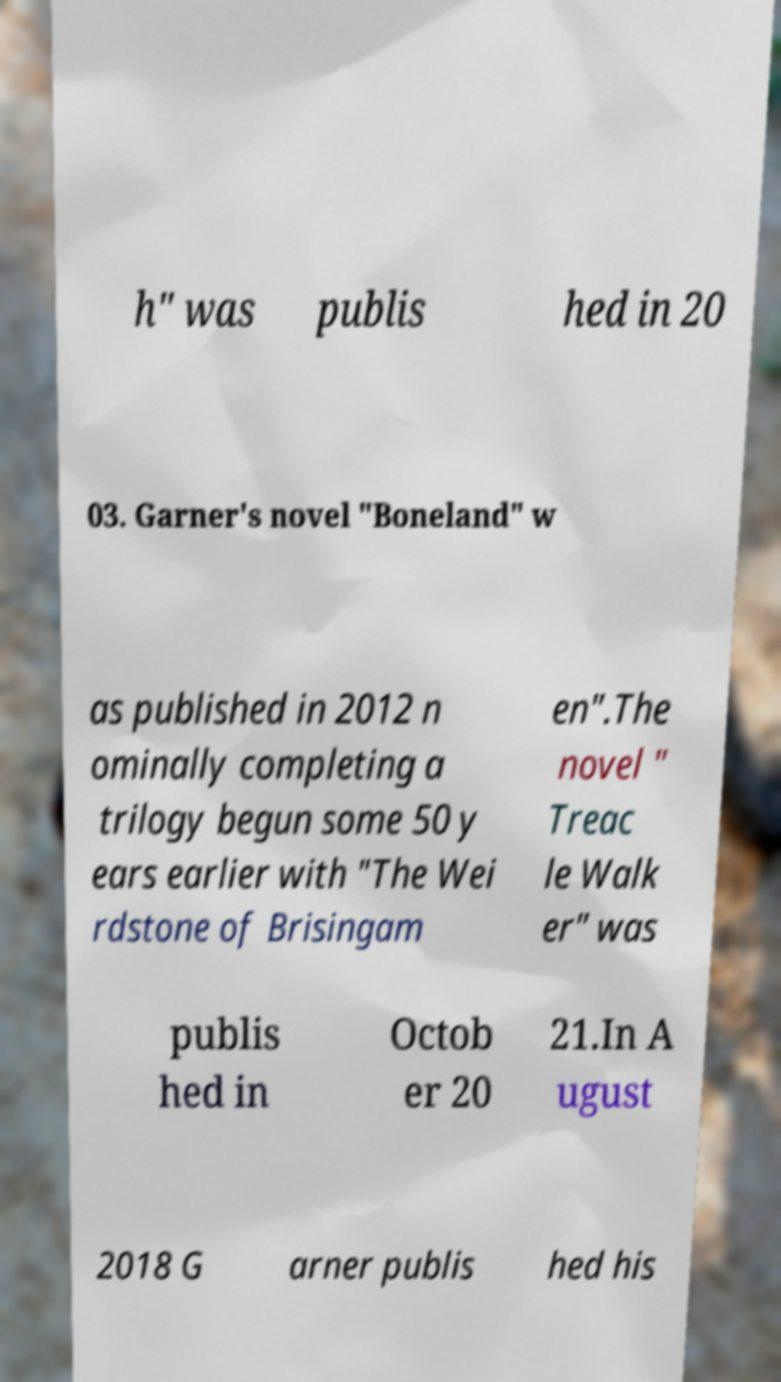For documentation purposes, I need the text within this image transcribed. Could you provide that? h" was publis hed in 20 03. Garner's novel "Boneland" w as published in 2012 n ominally completing a trilogy begun some 50 y ears earlier with "The Wei rdstone of Brisingam en".The novel " Treac le Walk er" was publis hed in Octob er 20 21.In A ugust 2018 G arner publis hed his 